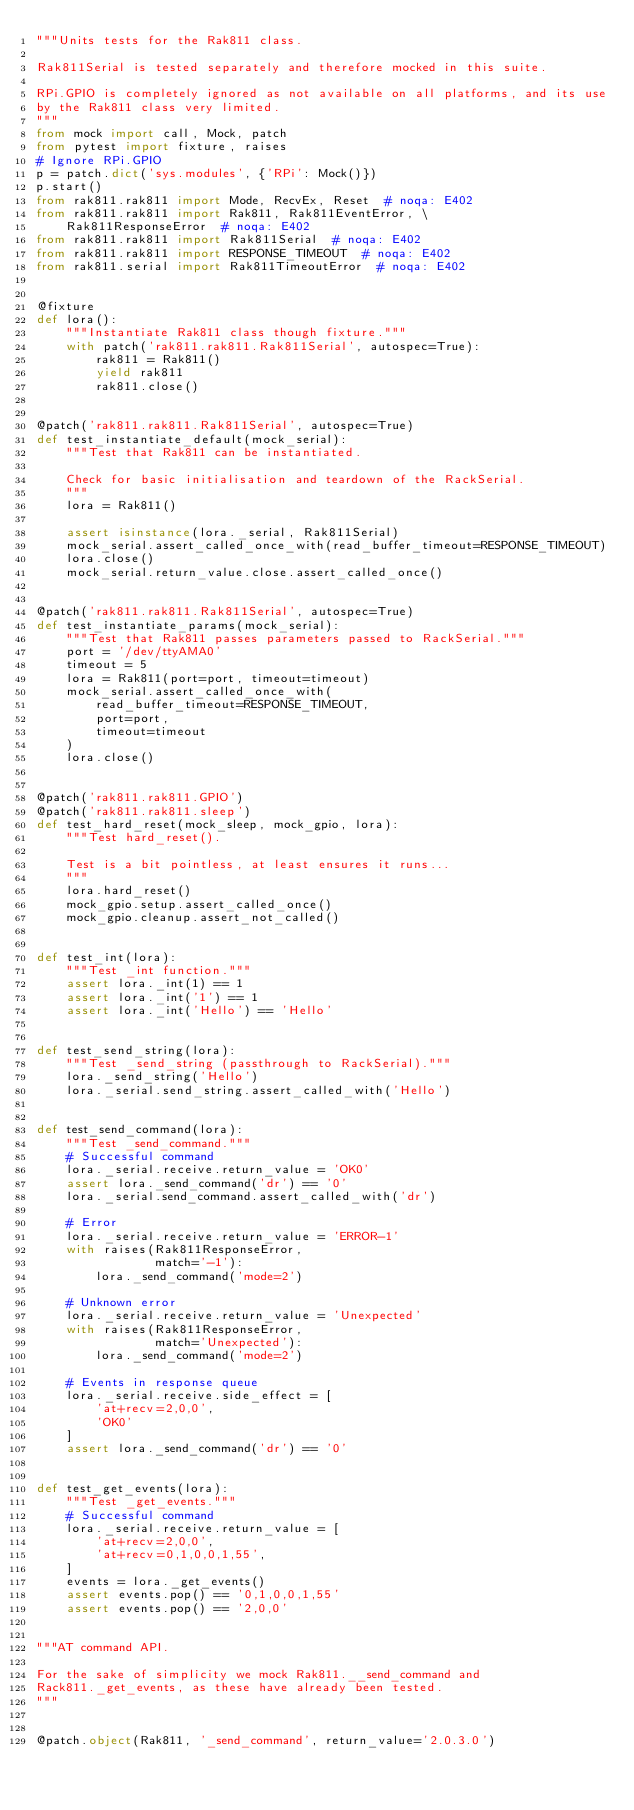<code> <loc_0><loc_0><loc_500><loc_500><_Python_>"""Units tests for the Rak811 class.

Rak811Serial is tested separately and therefore mocked in this suite.

RPi.GPIO is completely ignored as not available on all platforms, and its use
by the Rak811 class very limited.
"""
from mock import call, Mock, patch
from pytest import fixture, raises
# Ignore RPi.GPIO
p = patch.dict('sys.modules', {'RPi': Mock()})
p.start()
from rak811.rak811 import Mode, RecvEx, Reset  # noqa: E402
from rak811.rak811 import Rak811, Rak811EventError, \
    Rak811ResponseError  # noqa: E402
from rak811.rak811 import Rak811Serial  # noqa: E402
from rak811.rak811 import RESPONSE_TIMEOUT  # noqa: E402
from rak811.serial import Rak811TimeoutError  # noqa: E402


@fixture
def lora():
    """Instantiate Rak811 class though fixture."""
    with patch('rak811.rak811.Rak811Serial', autospec=True):
        rak811 = Rak811()
        yield rak811
        rak811.close()


@patch('rak811.rak811.Rak811Serial', autospec=True)
def test_instantiate_default(mock_serial):
    """Test that Rak811 can be instantiated.

    Check for basic initialisation and teardown of the RackSerial.
    """
    lora = Rak811()

    assert isinstance(lora._serial, Rak811Serial)
    mock_serial.assert_called_once_with(read_buffer_timeout=RESPONSE_TIMEOUT)
    lora.close()
    mock_serial.return_value.close.assert_called_once()


@patch('rak811.rak811.Rak811Serial', autospec=True)
def test_instantiate_params(mock_serial):
    """Test that Rak811 passes parameters passed to RackSerial."""
    port = '/dev/ttyAMA0'
    timeout = 5
    lora = Rak811(port=port, timeout=timeout)
    mock_serial.assert_called_once_with(
        read_buffer_timeout=RESPONSE_TIMEOUT,
        port=port,
        timeout=timeout
    )
    lora.close()


@patch('rak811.rak811.GPIO')
@patch('rak811.rak811.sleep')
def test_hard_reset(mock_sleep, mock_gpio, lora):
    """Test hard_reset().

    Test is a bit pointless, at least ensures it runs...
    """
    lora.hard_reset()
    mock_gpio.setup.assert_called_once()
    mock_gpio.cleanup.assert_not_called()


def test_int(lora):
    """Test _int function."""
    assert lora._int(1) == 1
    assert lora._int('1') == 1
    assert lora._int('Hello') == 'Hello'


def test_send_string(lora):
    """Test _send_string (passthrough to RackSerial)."""
    lora._send_string('Hello')
    lora._serial.send_string.assert_called_with('Hello')


def test_send_command(lora):
    """Test _send_command."""
    # Successful command
    lora._serial.receive.return_value = 'OK0'
    assert lora._send_command('dr') == '0'
    lora._serial.send_command.assert_called_with('dr')

    # Error
    lora._serial.receive.return_value = 'ERROR-1'
    with raises(Rak811ResponseError,
                match='-1'):
        lora._send_command('mode=2')

    # Unknown error
    lora._serial.receive.return_value = 'Unexpected'
    with raises(Rak811ResponseError,
                match='Unexpected'):
        lora._send_command('mode=2')

    # Events in response queue
    lora._serial.receive.side_effect = [
        'at+recv=2,0,0',
        'OK0'
    ]
    assert lora._send_command('dr') == '0'


def test_get_events(lora):
    """Test _get_events."""
    # Successful command
    lora._serial.receive.return_value = [
        'at+recv=2,0,0',
        'at+recv=0,1,0,0,1,55',
    ]
    events = lora._get_events()
    assert events.pop() == '0,1,0,0,1,55'
    assert events.pop() == '2,0,0'


"""AT command API.

For the sake of simplicity we mock Rak811.__send_command and
Rack811._get_events, as these have already been tested.
"""


@patch.object(Rak811, '_send_command', return_value='2.0.3.0')</code> 